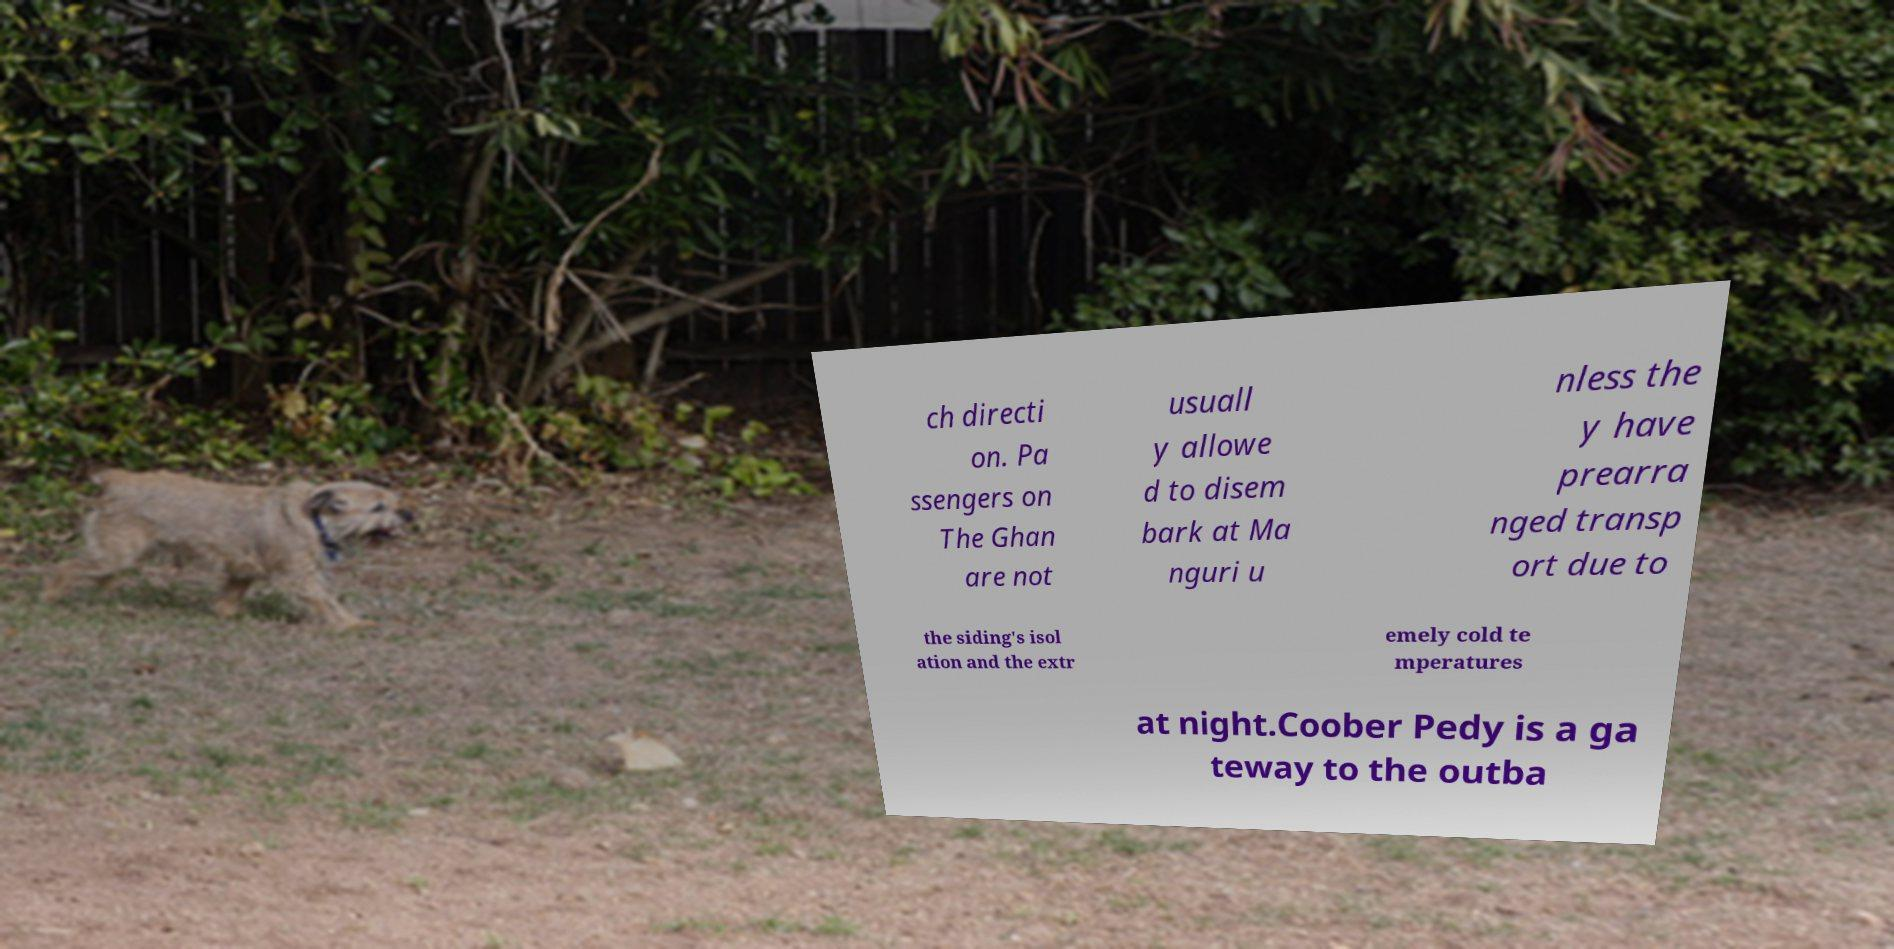What messages or text are displayed in this image? I need them in a readable, typed format. ch directi on. Pa ssengers on The Ghan are not usuall y allowe d to disem bark at Ma nguri u nless the y have prearra nged transp ort due to the siding's isol ation and the extr emely cold te mperatures at night.Coober Pedy is a ga teway to the outba 